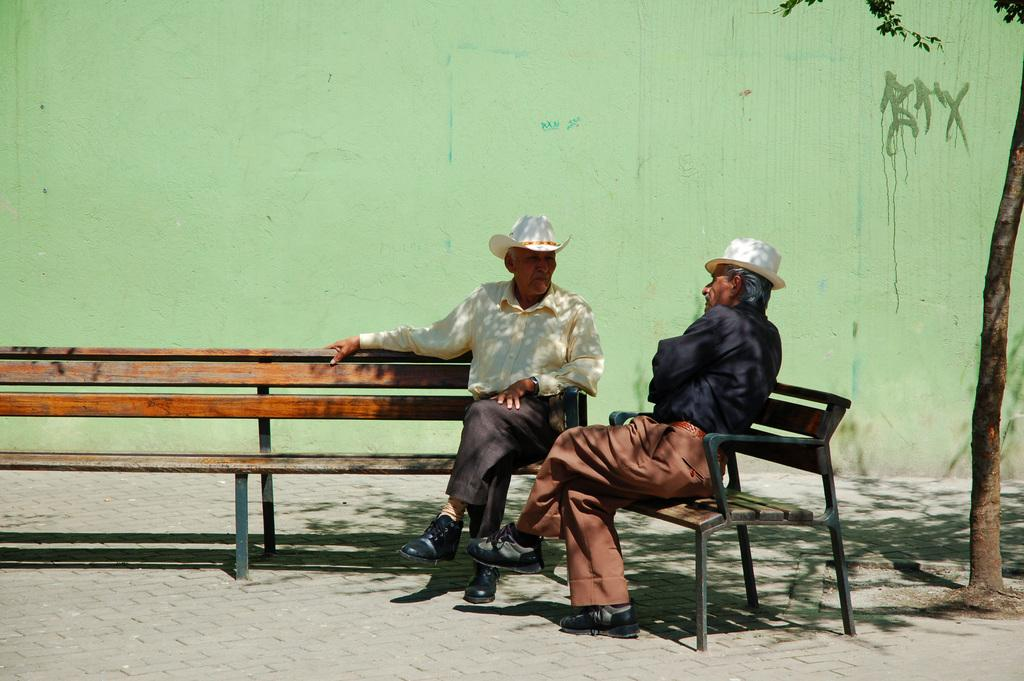How many people are in the image? There are two men in the image. What are the men doing in the image? The men are sitting on benches. What are the men wearing on their heads? The men are wearing hats. What can be seen in the background of the image? There is a wall and a tree in the background of the image. Reasoning: Let' Let's think step by step in order to produce the conversation. We start by identifying the number of people in the image, which is two men. Then, we describe their actions, noting that they are sitting on benches. Next, we mention their attire, specifically the hats they are wearing. Finally, we describe the background of the image, which includes a wall and a tree. Absurd Question/Answer: What type of discovery did the men make while sitting on the benches in the image? There is no indication of a discovery in the image; the men are simply sitting on benches. What type of oven can be seen in the image? There is no oven present in the image. 